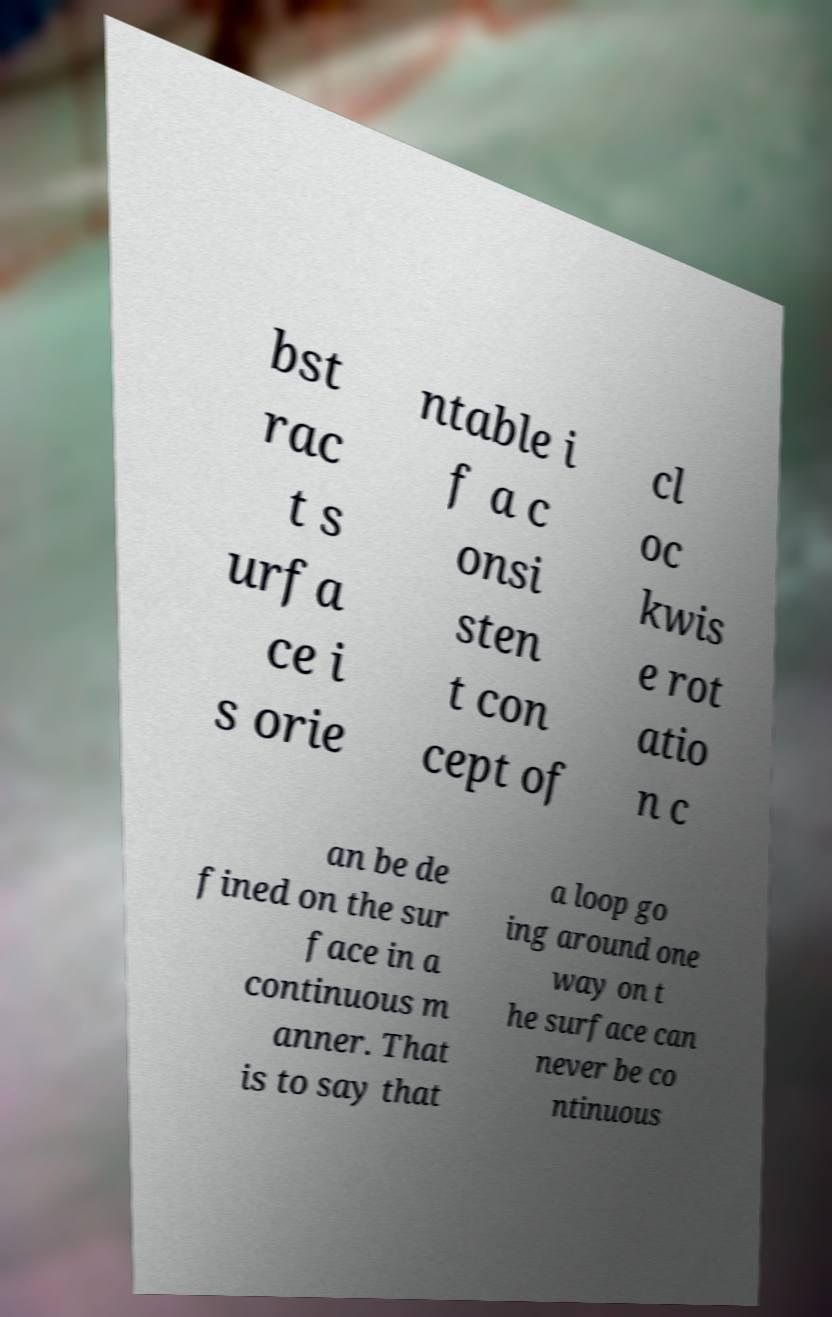There's text embedded in this image that I need extracted. Can you transcribe it verbatim? bst rac t s urfa ce i s orie ntable i f a c onsi sten t con cept of cl oc kwis e rot atio n c an be de fined on the sur face in a continuous m anner. That is to say that a loop go ing around one way on t he surface can never be co ntinuous 